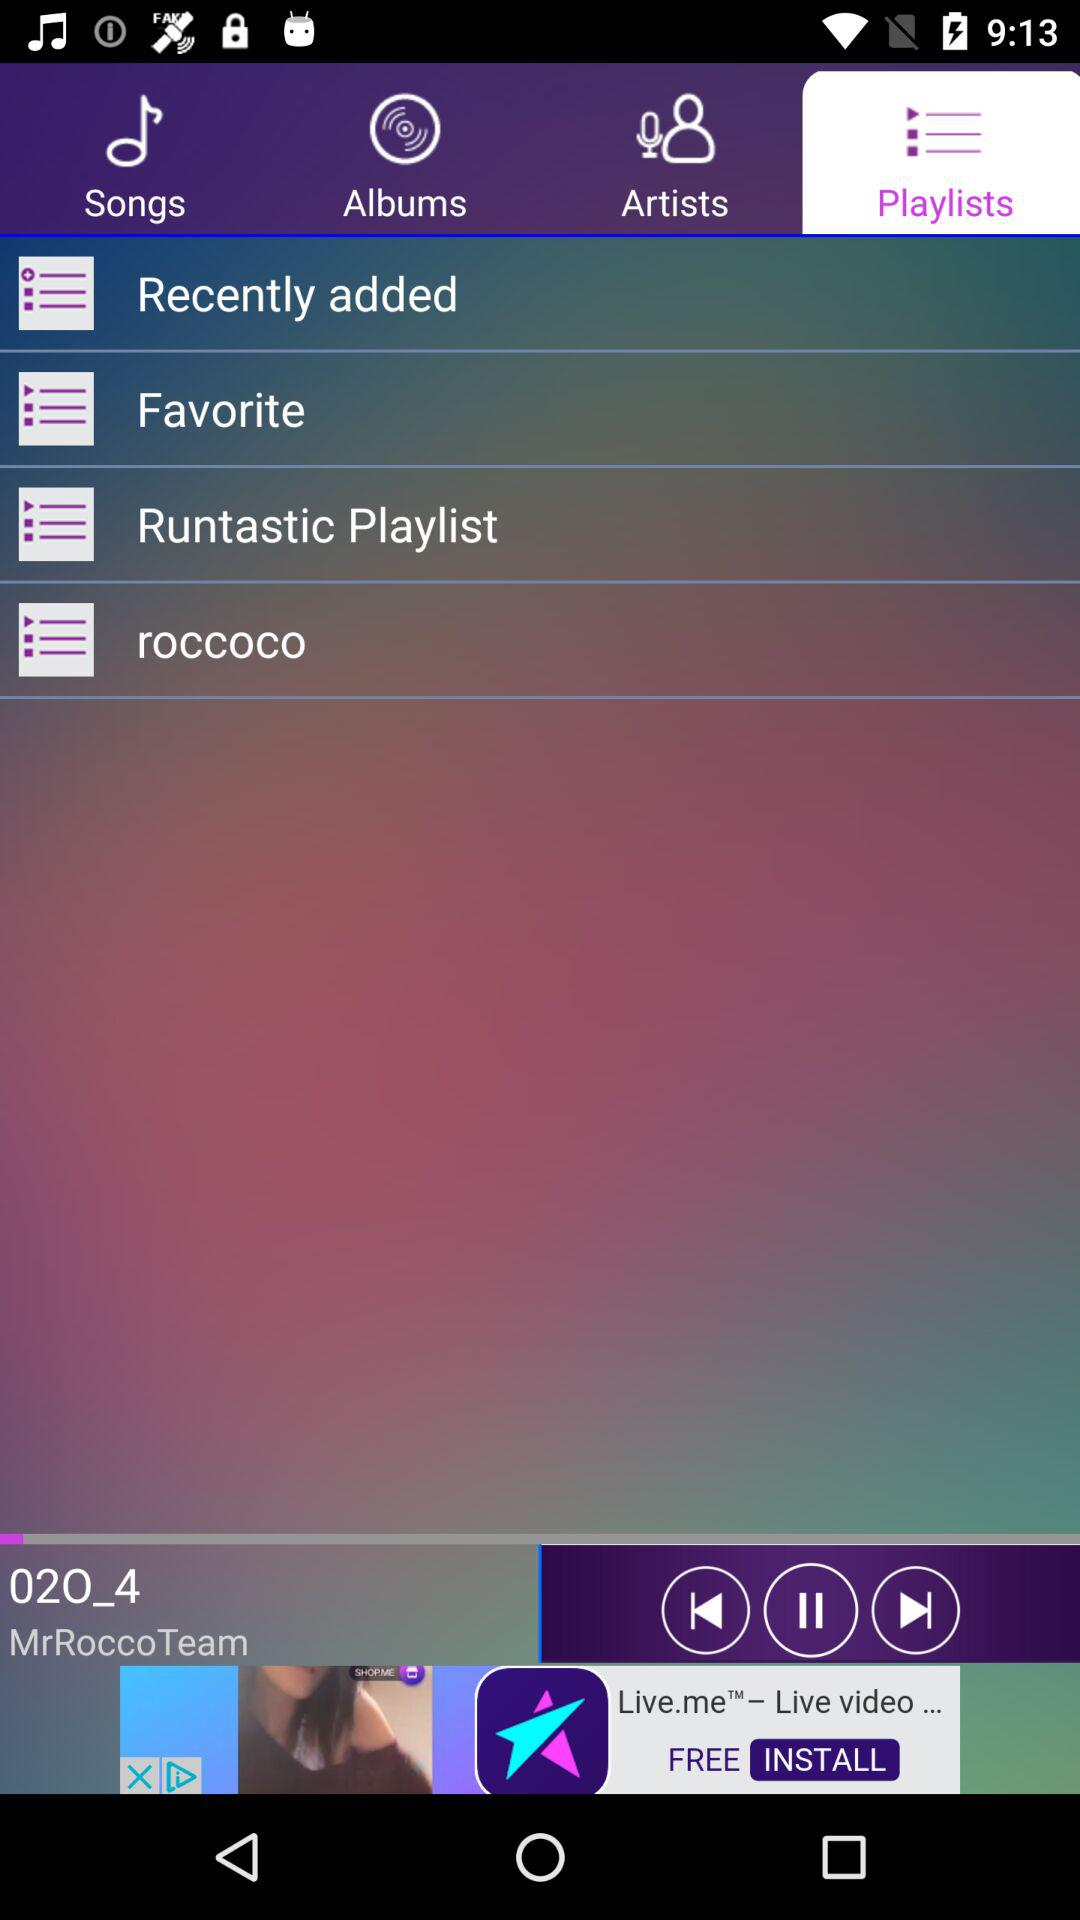What is the name of the song that is playing? The name of the song is "02O_4". 